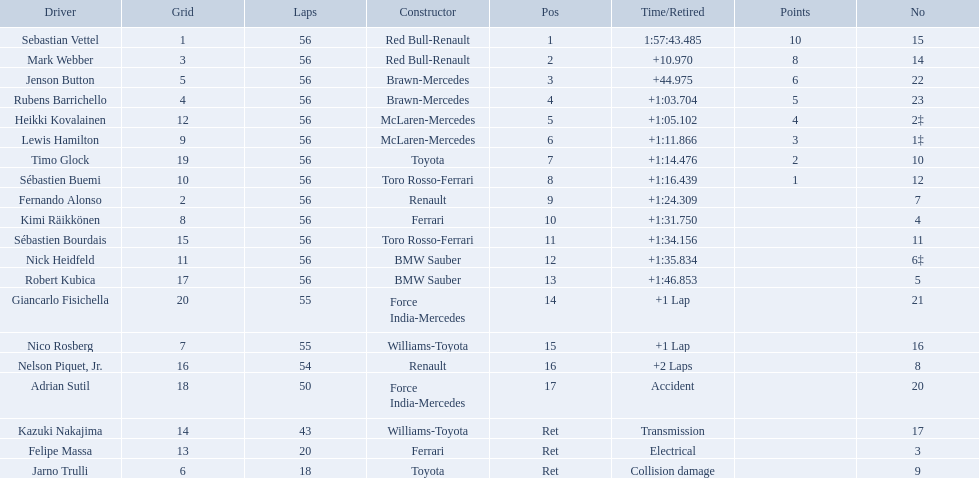Who were all of the drivers in the 2009 chinese grand prix? Sebastian Vettel, Mark Webber, Jenson Button, Rubens Barrichello, Heikki Kovalainen, Lewis Hamilton, Timo Glock, Sébastien Buemi, Fernando Alonso, Kimi Räikkönen, Sébastien Bourdais, Nick Heidfeld, Robert Kubica, Giancarlo Fisichella, Nico Rosberg, Nelson Piquet, Jr., Adrian Sutil, Kazuki Nakajima, Felipe Massa, Jarno Trulli. And what were their finishing times? 1:57:43.485, +10.970, +44.975, +1:03.704, +1:05.102, +1:11.866, +1:14.476, +1:16.439, +1:24.309, +1:31.750, +1:34.156, +1:35.834, +1:46.853, +1 Lap, +1 Lap, +2 Laps, Accident, Transmission, Electrical, Collision damage. Which player faced collision damage and retired from the race? Jarno Trulli. 